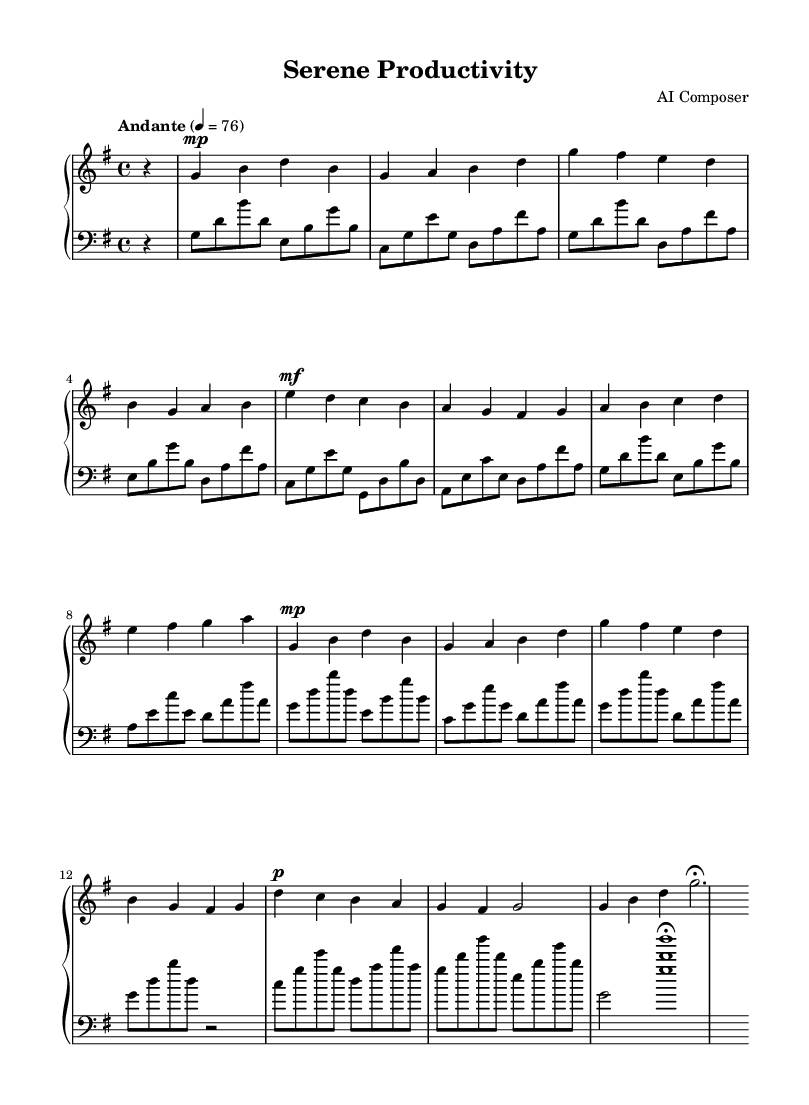What is the key signature of this music? The key signature is G major, which has one sharp (F#). We can tell this by looking at the key signature notation at the beginning of the sheet music.
Answer: G major What is the time signature of this music? The time signature is 4/4. This can be identified at the beginning of the score where the time signature is indicated. It shows that there are four beats per measure, and the quarter note gets one beat.
Answer: 4/4 What is the tempo marking for this piece? The tempo marking is "Andante" with a metronome marking of 76. This is noted above the staff and indicates a moderate walking pace.
Answer: Andante 4 = 76 How many measures are in the right hand part? There are a total of 8 measures in the right hand part. By counting the measures separated by bar lines, we can easily tally this number.
Answer: 8 What dynamics are indicated at the start of the right hand? The dynamics indicated are "mp" meaning "mezzo-piano," which directs the performer to play moderately softly. This is clearly marked at the beginning of the right hand staff.
Answer: mp What is the overall mood conveyed by the dynamics and tempo of this piece? The overall mood conveyed is calm and reflective, as indicated by the moderate tempo (Andante) and varying dynamics (from mp to mf). This suggests a peaceful and introspective character typical of Romantic compositions.
Answer: Calm How many distinct sections does the left hand have? The left hand has four distinct sections that can be identified through the use of different musical ideas and patterns that repeat throughout the score.
Answer: 4 